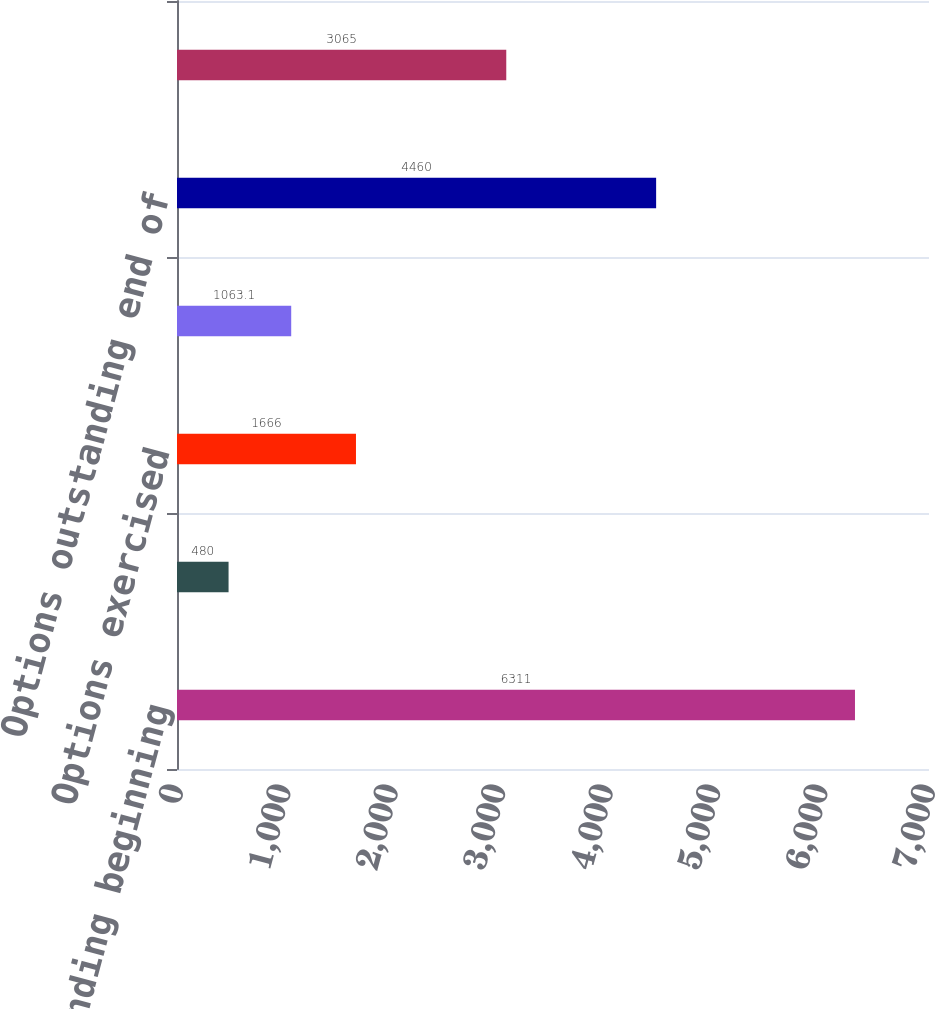<chart> <loc_0><loc_0><loc_500><loc_500><bar_chart><fcel>Options outstanding beginning<fcel>Options granted<fcel>Options exercised<fcel>Options forfeited<fcel>Options outstanding end of<fcel>Exercisable end of period<nl><fcel>6311<fcel>480<fcel>1666<fcel>1063.1<fcel>4460<fcel>3065<nl></chart> 